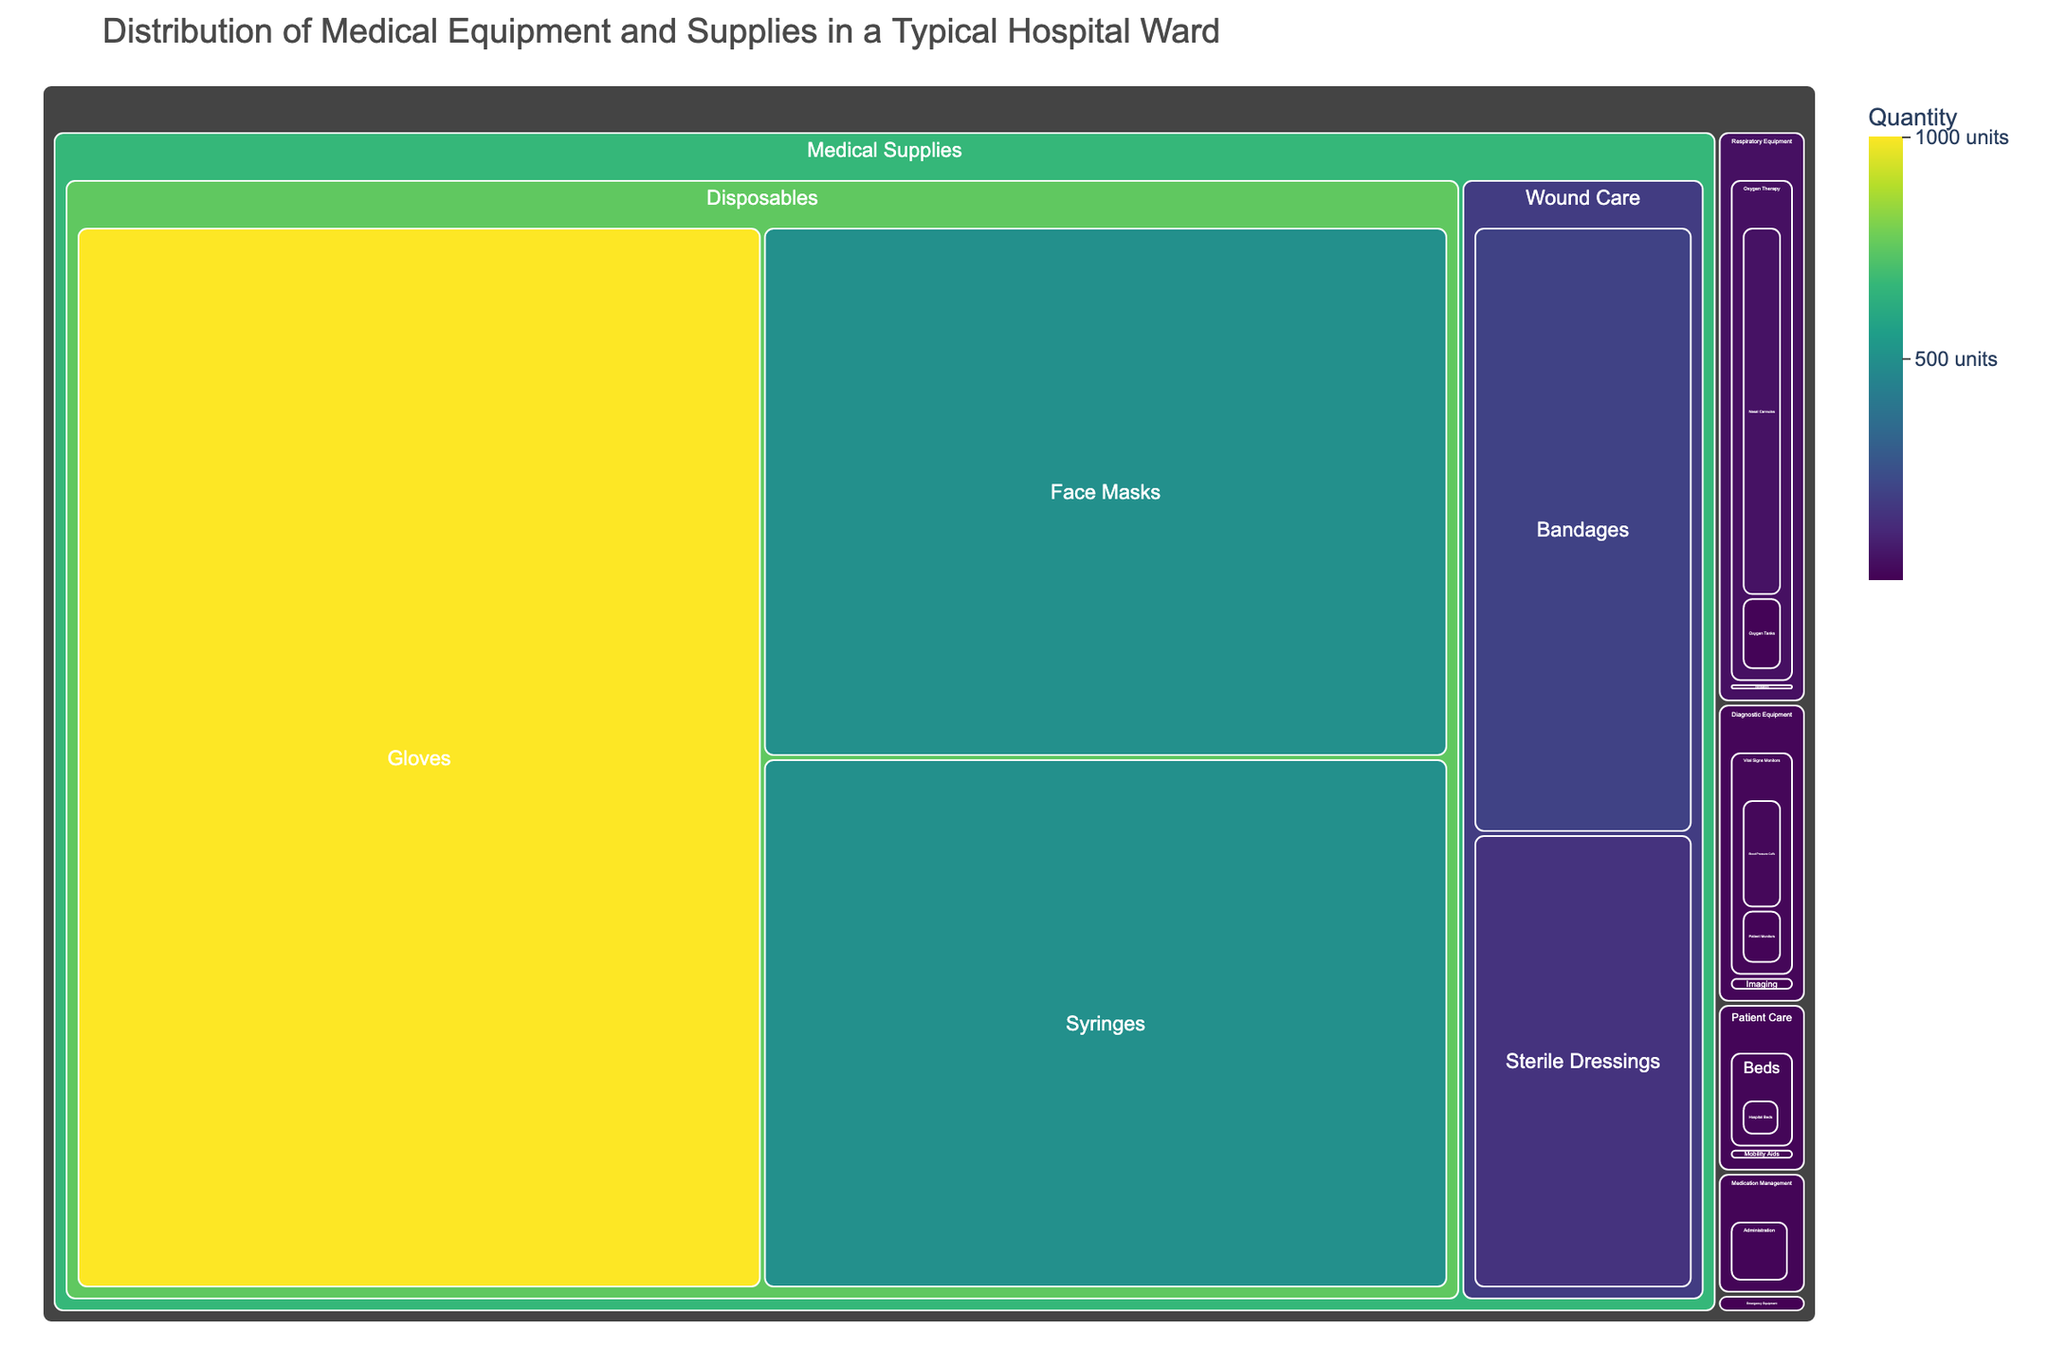What is the title of the treemap? The title is shown at the top of the treemap and summarizes the main subject of the data visualization. In this case, it reads "Distribution of Medical Equipment and Supplies in a Typical Hospital Ward."
Answer: Distribution of Medical Equipment and Supplies in a Typical Hospital Ward Which category has the highest total quantity of items? By visually inspecting the color intensity and area size, the "Medical Supplies" category shows the most vibrant colors and larger blocks indicating higher quantities. Specifically, "Disposables" under "Medical Supplies" with items like gloves and syringes contributes the most.
Answer: Medical Supplies How many subcategories are there under the "Patient Care" category? There are three subcategories under "Patient Care" as visually identified in the treemap: Beds, Mobility Aids, and Walkers.
Answer: 3 What item has the highest individual quantity, and what is that quantity? The item with the highest quantity is "Gloves" under the "Disposables" subcategory in "Medical Supplies," which is indicated by the color intensity and size of the block, and the quantity is 1000.
Answer: Gloves, 1000 How does the quantity of Oxygen Tanks compare to Ventilators? By comparing the blocks in the "Respiratory Equipment" category, "Oxygen Therapy" shows 10 Oxygen Tanks while "Ventilation" shows 3 Ventilators. Therefore, there are more Oxygen Tanks than Ventilators.
Answer: There are more Oxygen Tanks (10) than Ventilators (3) What is the combined quantity of Portable X-ray Machines and Ultrasound Machines? Both items fall under the "Imaging" subcategory of "Diagnostic Equipment." Portable X-ray Machines have a quantity of 2, and Ultrasound Machines have a quantity of 1. Adding them together, we get 2 + 1 = 3.
Answer: 3 Which category has the lowest representation in terms of the number of subcategories? By looking at the treemap, "Emergency Equipment" category appears to have the least number of subcategories, as it only contains "Resuscitation."
Answer: Emergency Equipment What is the difference between the quantities of Blood Pressure Cuffs and Patient Monitors? Referring to the "Vital Signs Monitors" subcategory in "Diagnostic Equipment," Blood Pressure Cuffs have a quantity of 20 and Patient Monitors have a quantity of 10. The difference is 20 - 10 = 10.
Answer: 10 How do the quantities of Hospital Beds and Stretchers compare? These items are under the "Beds" subcategory in "Patient Care." Hospital Beds have a quantity of 15, whereas Stretchers have a quantity of 5. Comparing these shows that Hospital Beds outnumber Stretchers.
Answer: Hospital Beds (15) outnumber Stretchers (5) What is the total quantity of items in the "Mobility Aids" subcategory? In the "Mobility Aids" subcategory of "Patient Care," Wheelchairs have a quantity of 8 and Walkers have a quantity of 6. Adding them together, we get 8 + 6 = 14.
Answer: 14 